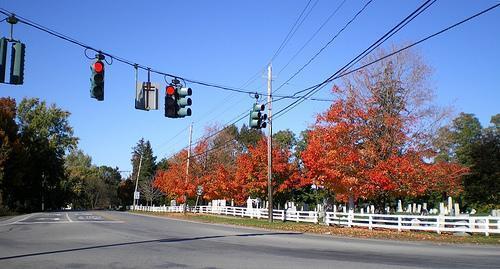How many blue bicycles are there?
Give a very brief answer. 0. 